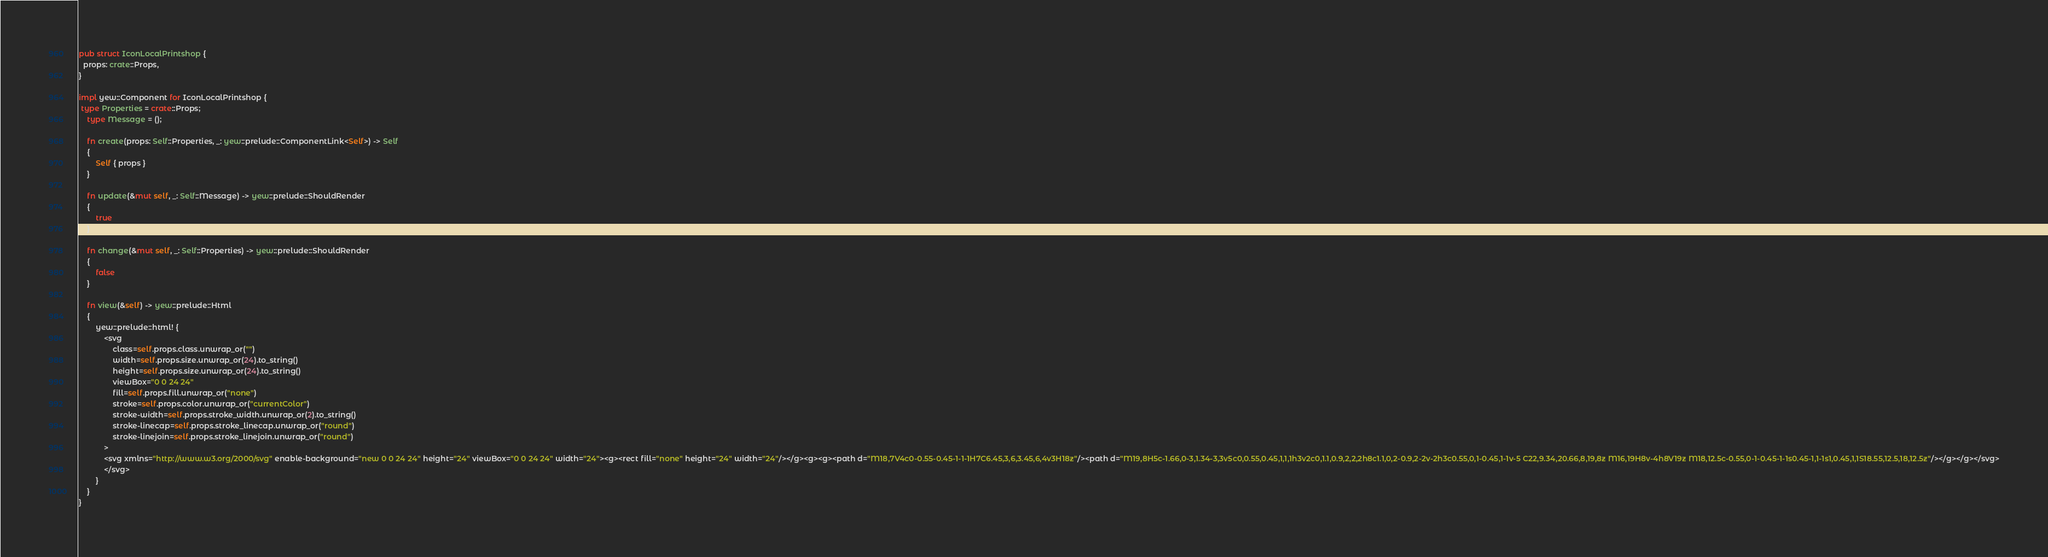Convert code to text. <code><loc_0><loc_0><loc_500><loc_500><_Rust_>
pub struct IconLocalPrintshop {
  props: crate::Props,
}

impl yew::Component for IconLocalPrintshop {
 type Properties = crate::Props;
    type Message = ();

    fn create(props: Self::Properties, _: yew::prelude::ComponentLink<Self>) -> Self
    {
        Self { props }
    }

    fn update(&mut self, _: Self::Message) -> yew::prelude::ShouldRender
    {
        true
    }

    fn change(&mut self, _: Self::Properties) -> yew::prelude::ShouldRender
    {
        false
    }

    fn view(&self) -> yew::prelude::Html
    {
        yew::prelude::html! {
            <svg
                class=self.props.class.unwrap_or("")
                width=self.props.size.unwrap_or(24).to_string()
                height=self.props.size.unwrap_or(24).to_string()
                viewBox="0 0 24 24"
                fill=self.props.fill.unwrap_or("none")
                stroke=self.props.color.unwrap_or("currentColor")
                stroke-width=self.props.stroke_width.unwrap_or(2).to_string()
                stroke-linecap=self.props.stroke_linecap.unwrap_or("round")
                stroke-linejoin=self.props.stroke_linejoin.unwrap_or("round")
            >
            <svg xmlns="http://www.w3.org/2000/svg" enable-background="new 0 0 24 24" height="24" viewBox="0 0 24 24" width="24"><g><rect fill="none" height="24" width="24"/></g><g><g><path d="M18,7V4c0-0.55-0.45-1-1-1H7C6.45,3,6,3.45,6,4v3H18z"/><path d="M19,8H5c-1.66,0-3,1.34-3,3v5c0,0.55,0.45,1,1,1h3v2c0,1.1,0.9,2,2,2h8c1.1,0,2-0.9,2-2v-2h3c0.55,0,1-0.45,1-1v-5 C22,9.34,20.66,8,19,8z M16,19H8v-4h8V19z M18,12.5c-0.55,0-1-0.45-1-1s0.45-1,1-1s1,0.45,1,1S18.55,12.5,18,12.5z"/></g></g></svg>
            </svg>
        }
    }
}


</code> 